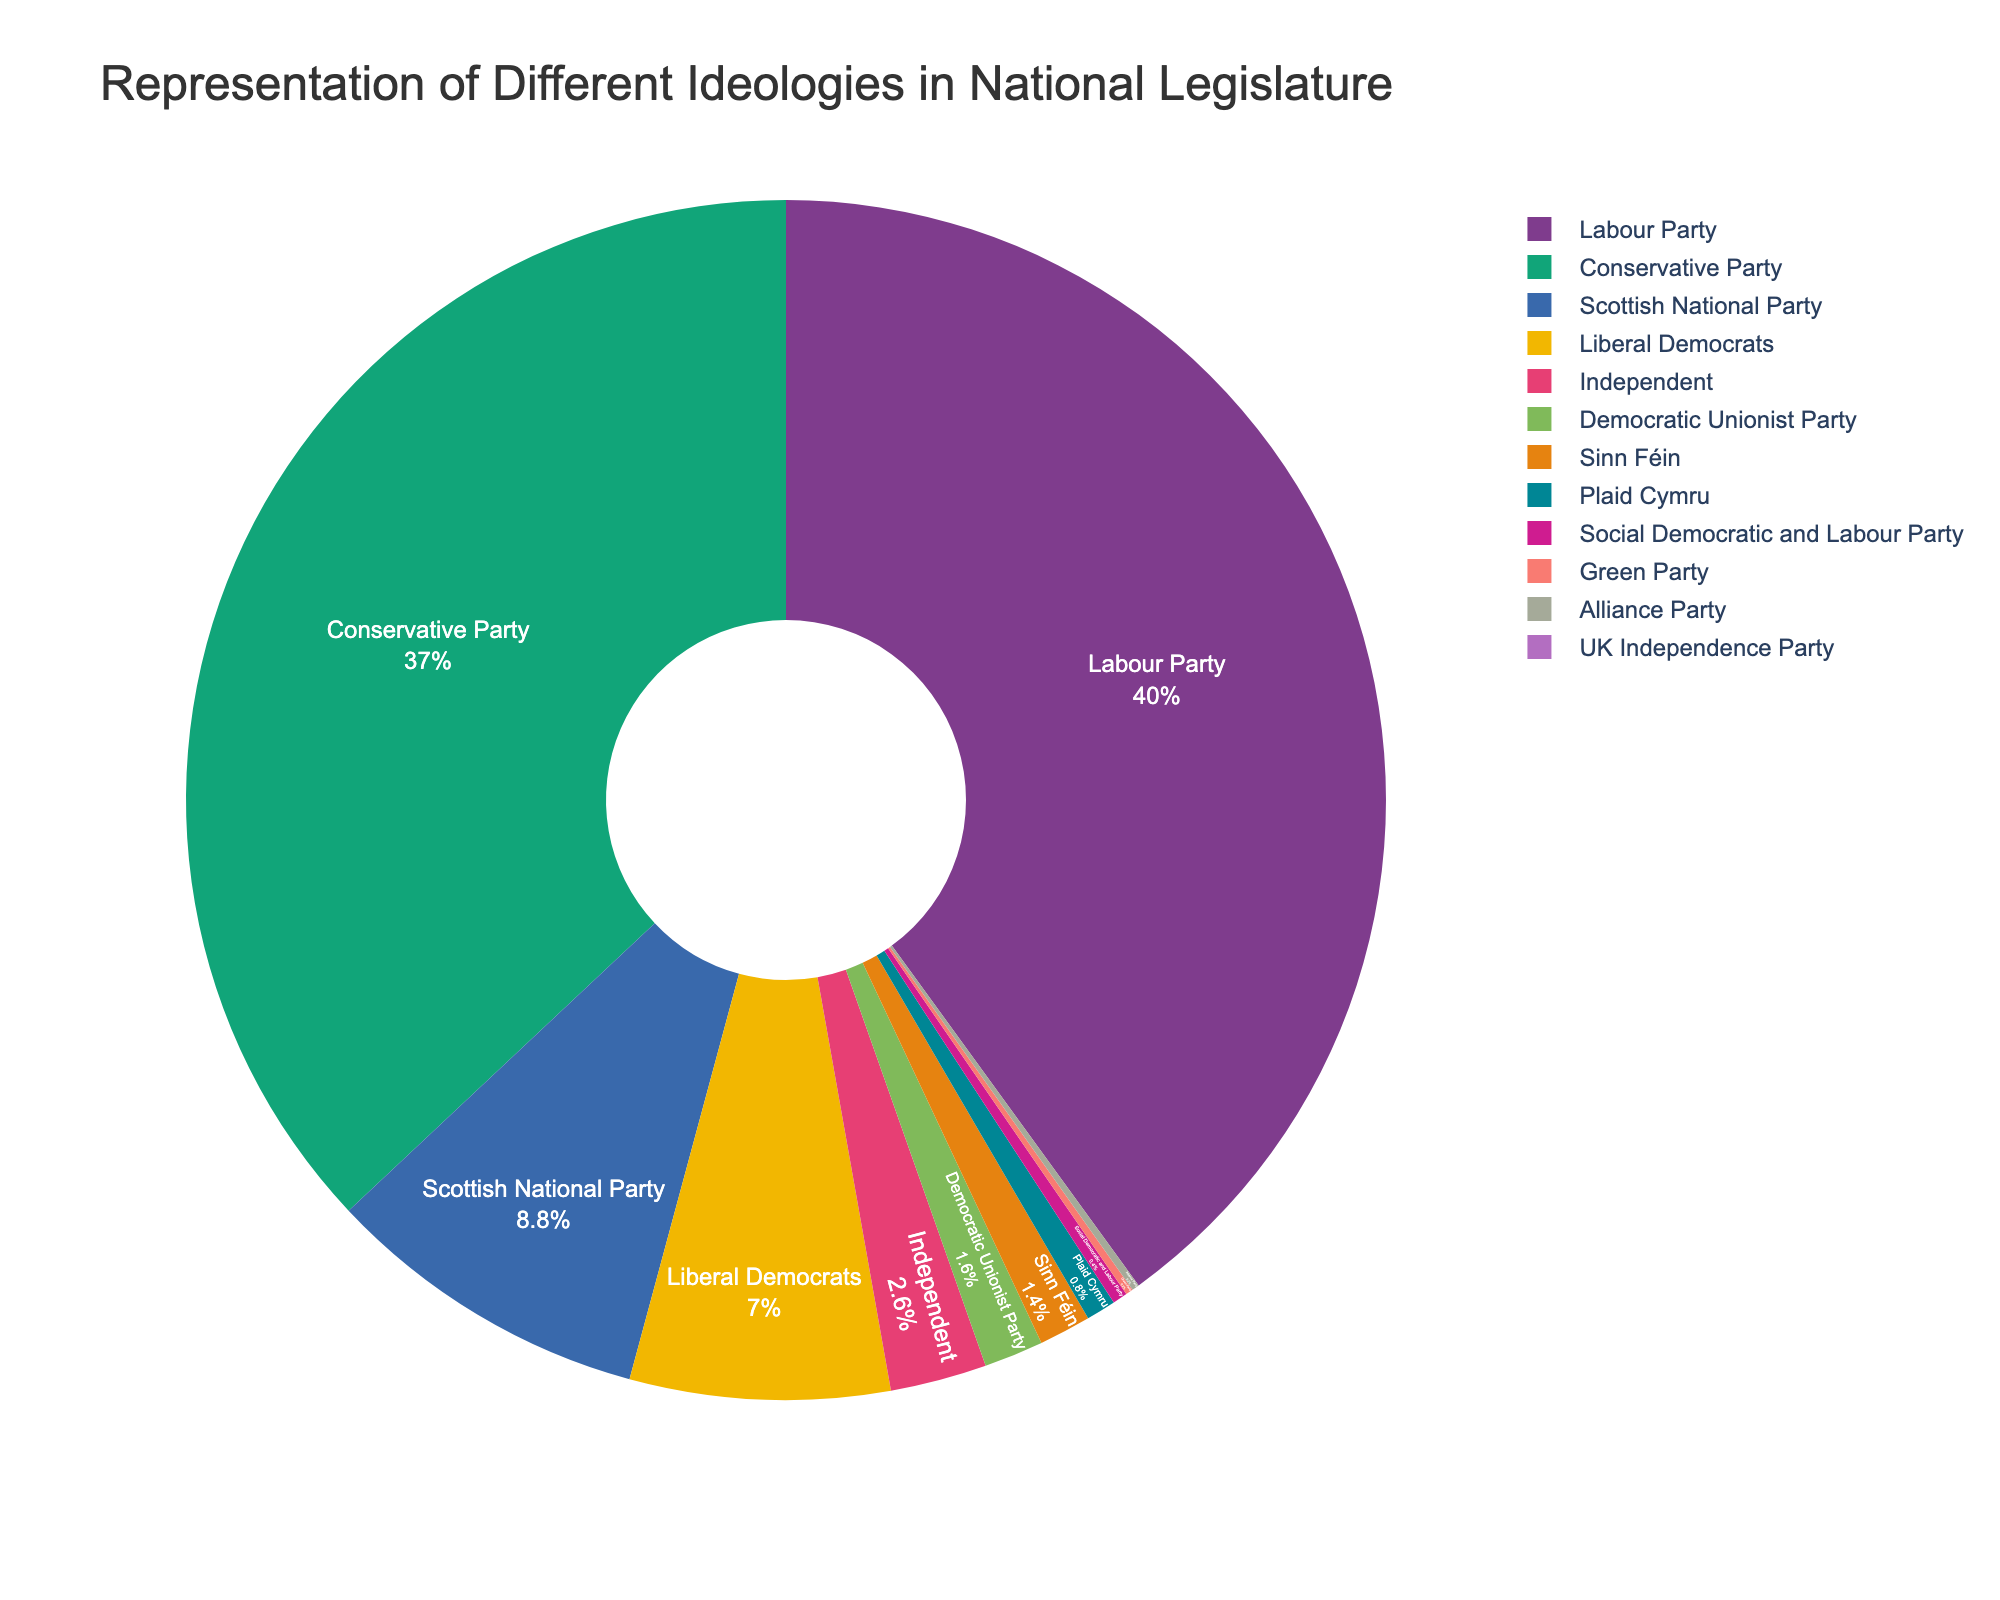What is the total number of seats held by the Conservative Party and the Labour Party combined? The Conservative Party has 185 seats, and the Labour Party has 200 seats. Adding them together gives 185 + 200 = 385.
Answer: 385 Which ideology holds the largest number of seats in the national legislature? The Labour Party holds the largest number of seats, with 200 seats.
Answer: Labour Party What percentage of the seats does the Scottish National Party hold? The Scottish National Party has 44 seats out of a total of 500 seats. To find the percentage: (44/500) * 100 = 8.8%.
Answer: 8.8% What is the difference in the number of seats between Liberal Democrats and Independent members? The Liberal Democrats hold 35 seats, and Independent members hold 13 seats. The difference is 35 - 13 = 22.
Answer: 22 How many more seats does the Labour Party have than the Conservative Party? The Labour Party has 200 seats, and the Conservative Party has 185 seats. The difference is 200 - 185 = 15.
Answer: 15 Which ideologies have an equal number of seats, and how many seats do they have? Both the Green Party and Alliance Party have 1 seat each.
Answer: Green Party and Alliance Party, 1 seat each How many seats are held by parties with fewer than 10 seats? Adding the seats for the Green Party (1), Plaid Cymru (4), Democratic Unionist Party (8), Sinn Féin (7), Social Democratic and Labour Party (2), and Alliance Party (1): 1 + 4 + 8 + 7 + 2 + 1 = 23.
Answer: 23 Which party is represented by the smallest section of the pie chart? The UK Independence Party has 0 seats, which is the smallest representation.
Answer: UK Independence Party What is the combined percentage of seats held by Plaid Cymru, Democratic Unionist Party, and Sinn Féin? Plaid Cymru has 4 seats, Democratic Unionist Party has 8 seats, and Sinn Féin has 7 seats. The combined total is 4 + 8 + 7 = 19 seats. To find the percentage: (19/500) * 100 = 3.8%.
Answer: 3.8% What is the color of the section representing the Labour Party? The Labour Party is represented by a specific color in the pie chart, which needs to be visually identified.
Answer: [Color of the Labour Party section] 